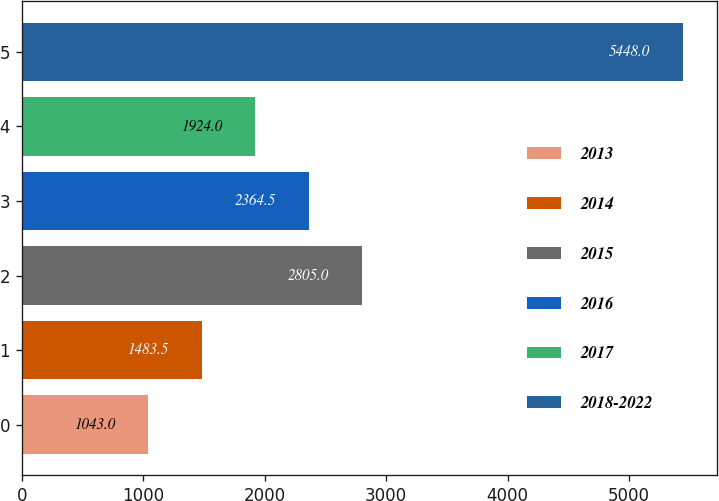<chart> <loc_0><loc_0><loc_500><loc_500><bar_chart><fcel>2013<fcel>2014<fcel>2015<fcel>2016<fcel>2017<fcel>2018-2022<nl><fcel>1043<fcel>1483.5<fcel>2805<fcel>2364.5<fcel>1924<fcel>5448<nl></chart> 